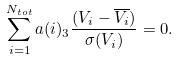<formula> <loc_0><loc_0><loc_500><loc_500>\sum _ { i = 1 } ^ { N _ { t o t } } a ( i ) _ { 3 } \frac { ( V _ { i } - \overline { V _ { i } } ) } { \sigma ( V _ { i } ) } = 0 .</formula> 